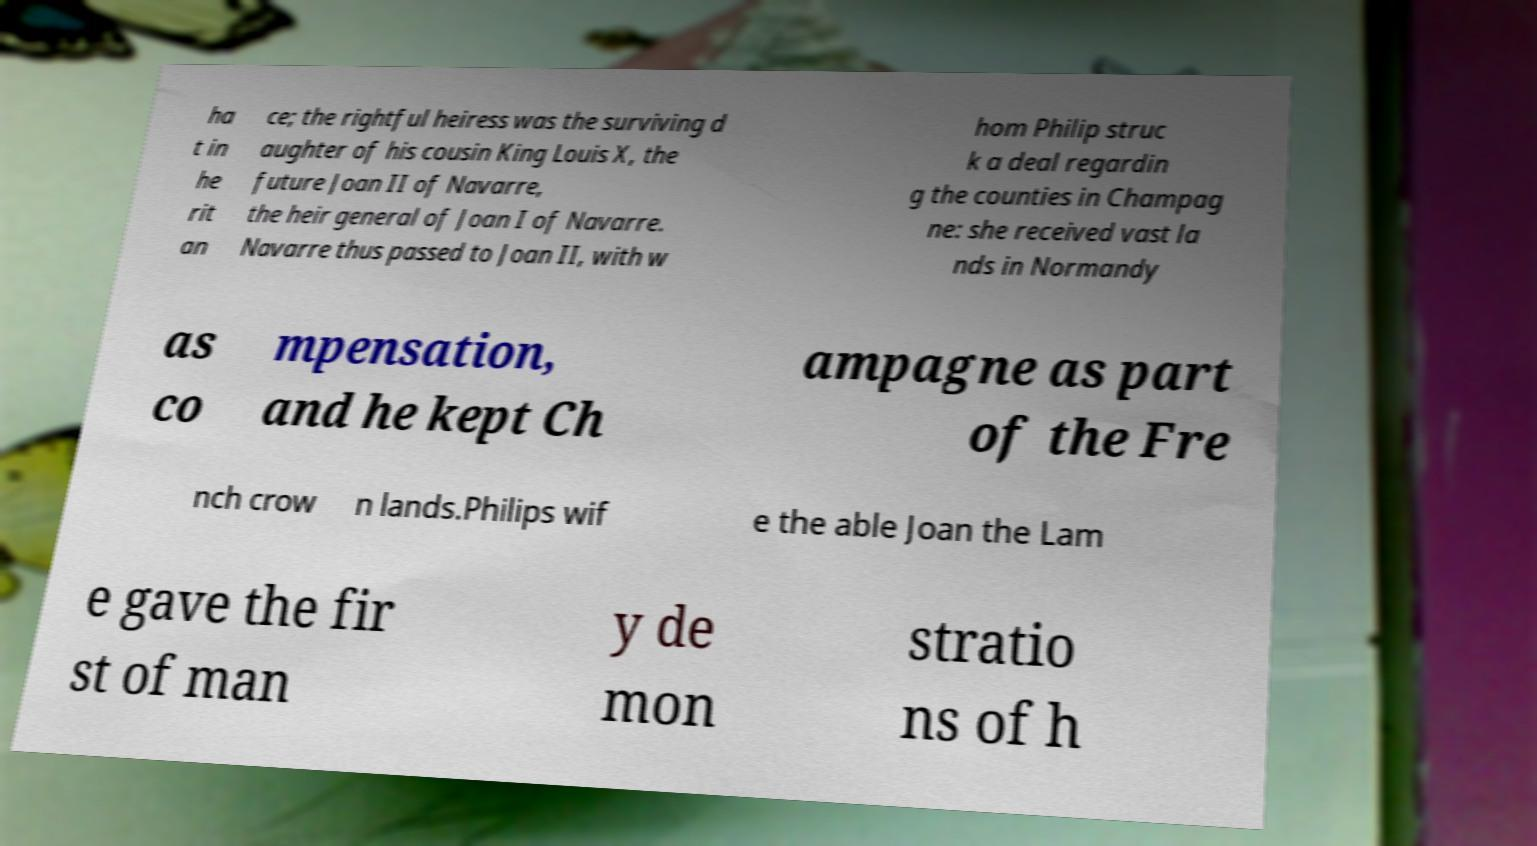What messages or text are displayed in this image? I need them in a readable, typed format. ha t in he rit an ce; the rightful heiress was the surviving d aughter of his cousin King Louis X, the future Joan II of Navarre, the heir general of Joan I of Navarre. Navarre thus passed to Joan II, with w hom Philip struc k a deal regardin g the counties in Champag ne: she received vast la nds in Normandy as co mpensation, and he kept Ch ampagne as part of the Fre nch crow n lands.Philips wif e the able Joan the Lam e gave the fir st of man y de mon stratio ns of h 